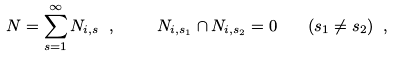<formula> <loc_0><loc_0><loc_500><loc_500>N = \sum _ { s = 1 } ^ { \infty } N _ { i , s } \ , \ \quad N _ { i , s _ { 1 } } \cap N _ { i , s _ { 2 } } = 0 \quad ( s _ { 1 } \neq s _ { 2 } ) \ ,</formula> 